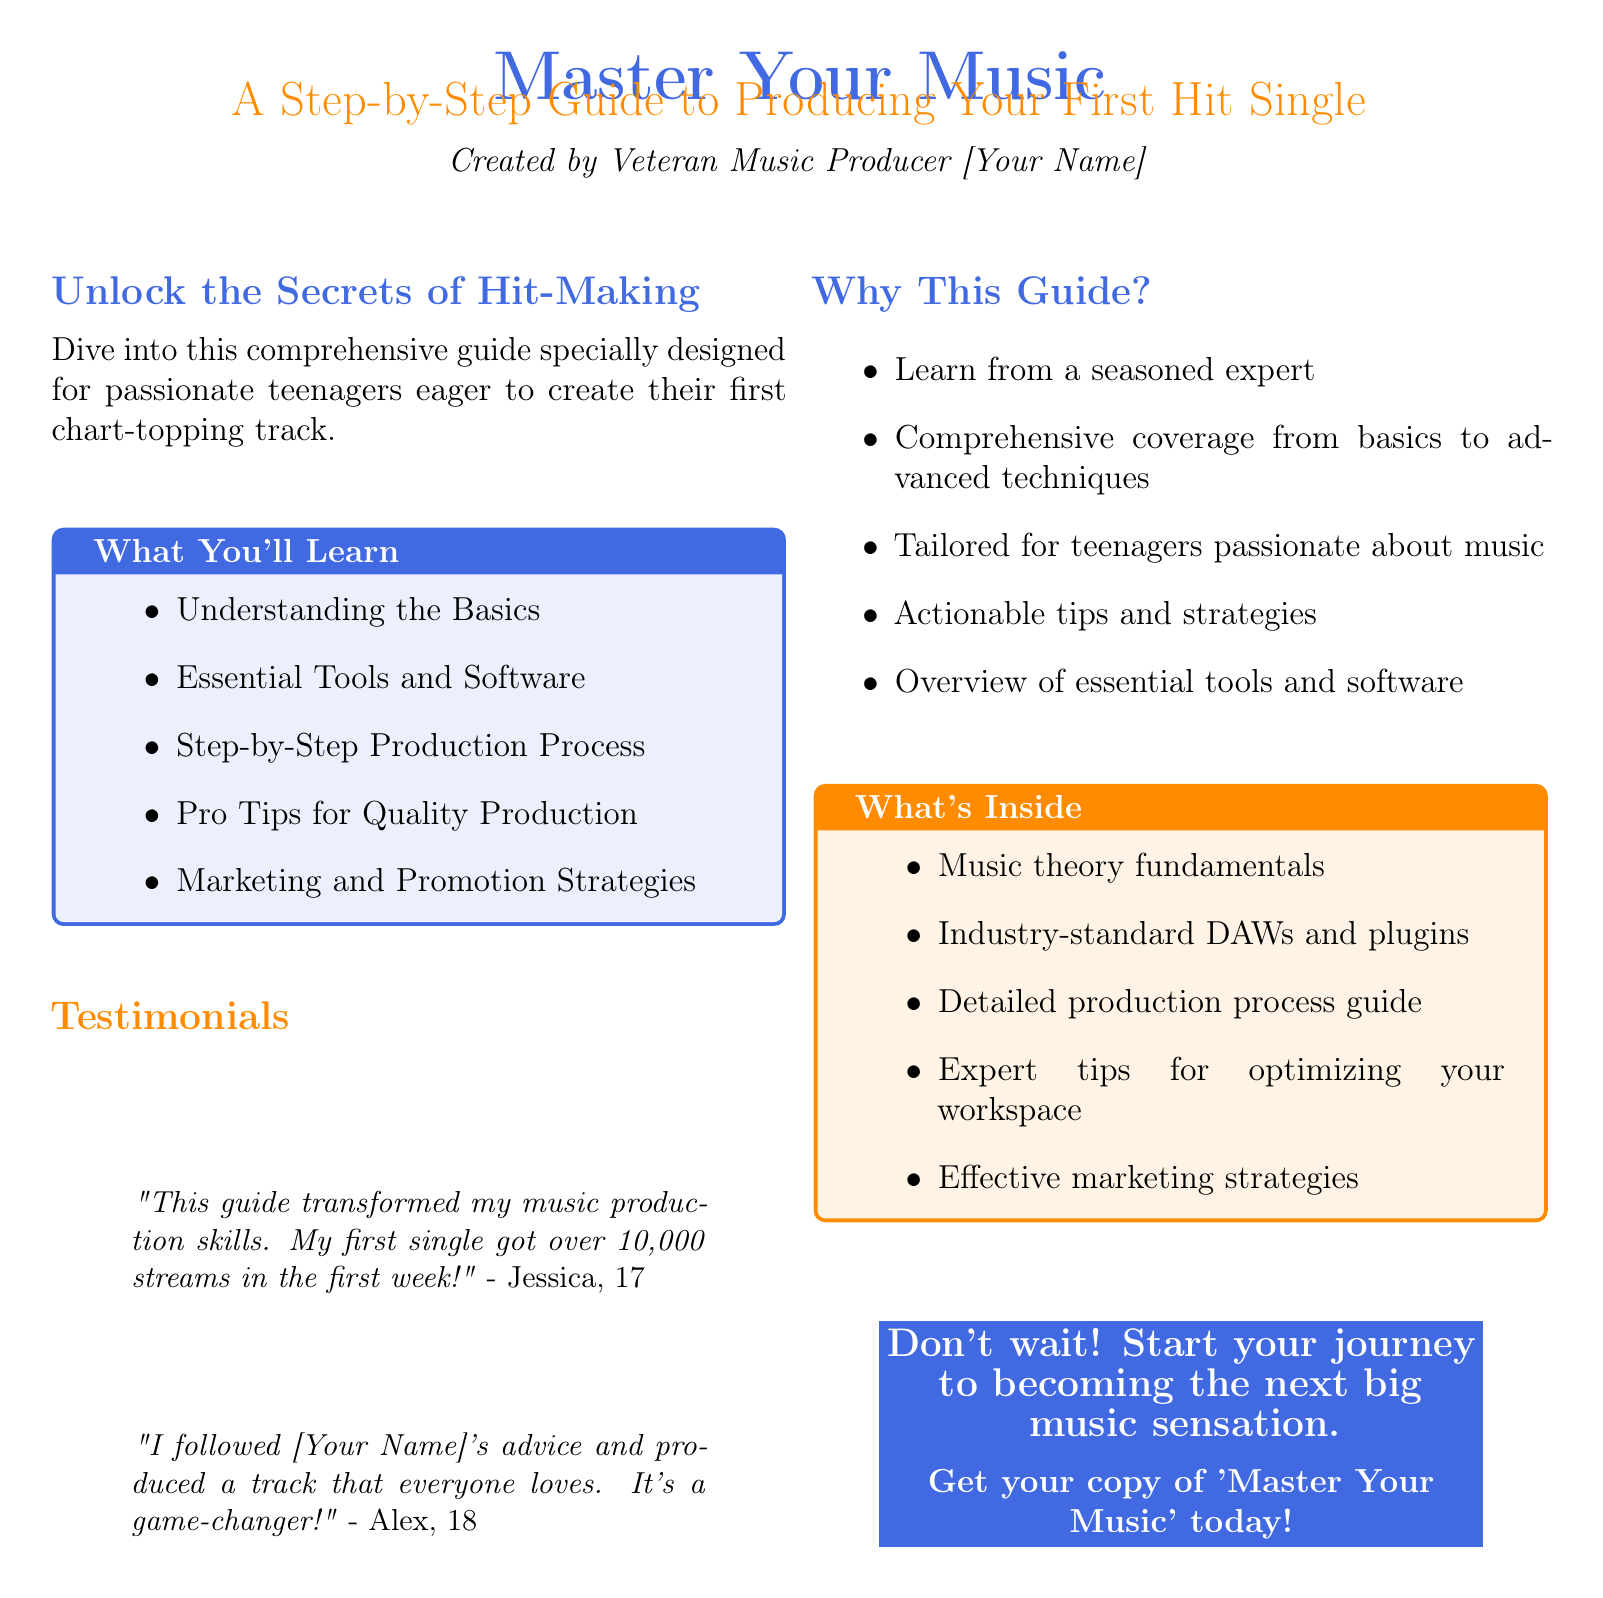What is the title of the guide? The title of the guide is the main focus of the document and is clearly stated at the top.
Answer: Master Your Music Who is the guide created by? The document includes the creator's name as a veteran music producer, which is important for credibility.
Answer: [Your Name] How many testimonials are included in the advertisement? The number of testimonials is specified in the document and reflects feedback from young artists.
Answer: 2 What is the age of Jessica, who provided a testimonial? Jessica's age is provided in the testimonial section, contributing to the target audience's relatability.
Answer: 17 What essential topic is included in the "What's Inside" section? This section provides a specific list of topics that the guide covers, giving potential readers insight into the content.
Answer: Music theory fundamentals What color is the main title text? The color of the main title is an important design element that draws attention to the title.
Answer: RGB(65,105,225) What is the overall aim of the guide as described? The document's purpose is to encourage teenagers to pursue their passion for music production, and this is outlined clearly.
Answer: Create their first chart-topping track What type of guide is "Master Your Music"? The classification of the guide helps to understand its intent and structure.
Answer: Step-by-Step Guide 